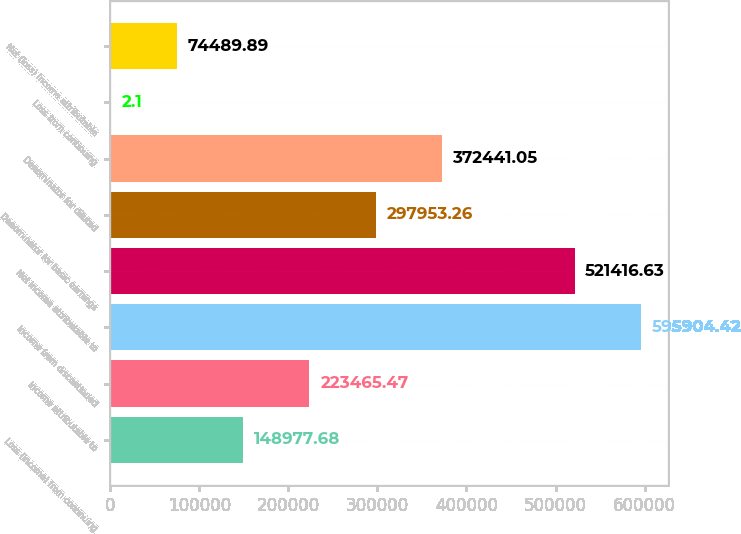<chart> <loc_0><loc_0><loc_500><loc_500><bar_chart><fcel>Loss (income) from continuing<fcel>Income attributable to<fcel>Income from discontinued<fcel>Net income attributable to<fcel>Denominator for basic earnings<fcel>Denominator for diluted<fcel>Loss from continuing<fcel>Net (loss) income attributable<nl><fcel>148978<fcel>223465<fcel>595904<fcel>521417<fcel>297953<fcel>372441<fcel>2.1<fcel>74489.9<nl></chart> 